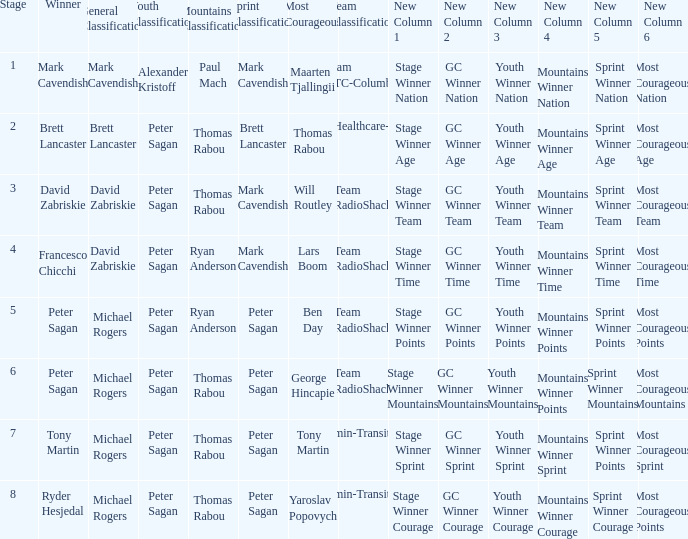When Yaroslav Popovych won most corageous, who won the mountains classification? Thomas Rabou. 